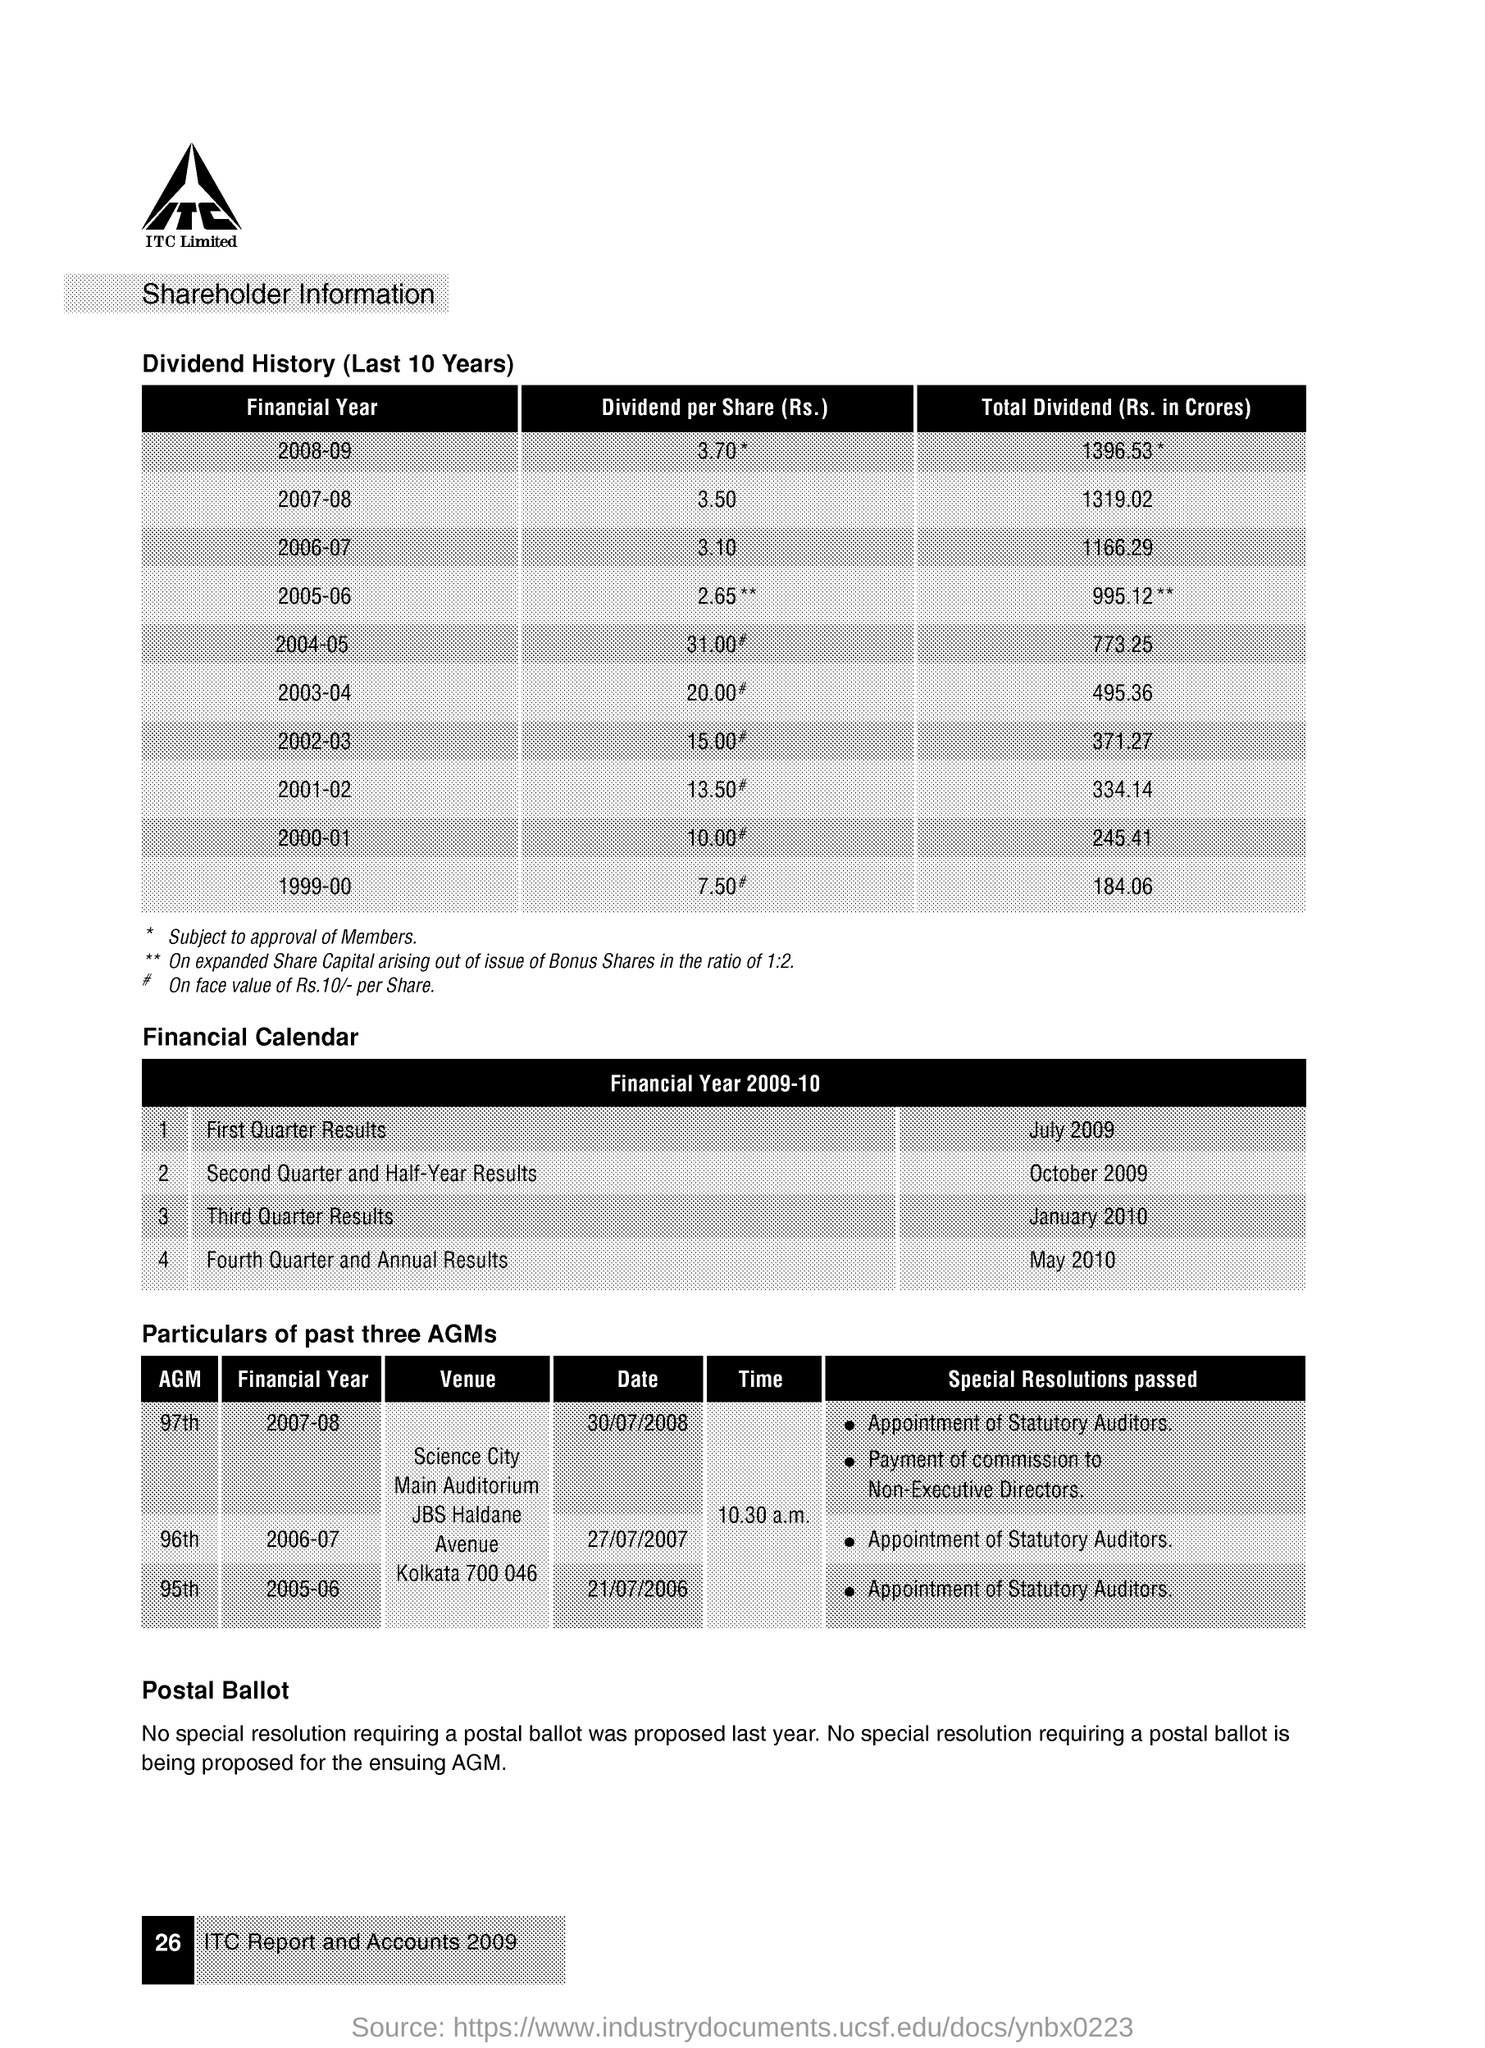What significant changes occurred in the financial year 2008-09 according to the document in the image? In the financial year 2008-09, there was a slight increase in dividend per share from 3.10 in the previous year to 3.70. However, it's significant to note that the total dividend paid out saw a substantial jump to 1396.53 crores from 1166.29 crores in the previous financial year. 